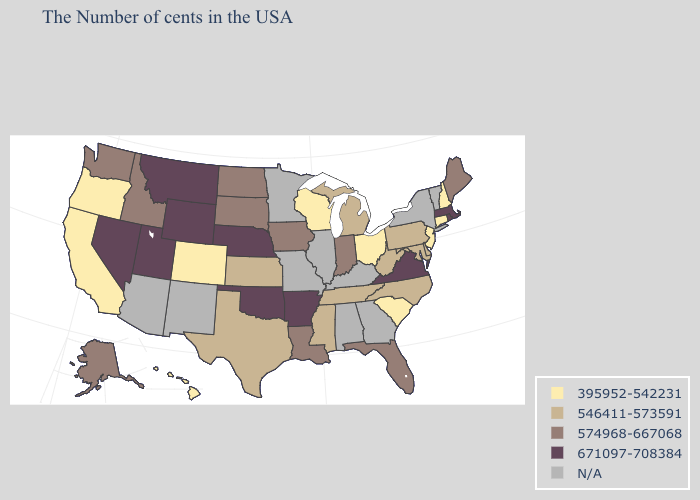Among the states that border Tennessee , does Virginia have the highest value?
Answer briefly. Yes. Name the states that have a value in the range 574968-667068?
Answer briefly. Maine, Florida, Indiana, Louisiana, Iowa, South Dakota, North Dakota, Idaho, Washington, Alaska. Does the first symbol in the legend represent the smallest category?
Short answer required. Yes. Which states have the highest value in the USA?
Short answer required. Massachusetts, Rhode Island, Virginia, Arkansas, Nebraska, Oklahoma, Wyoming, Utah, Montana, Nevada. Which states have the lowest value in the South?
Answer briefly. South Carolina. What is the value of Tennessee?
Be succinct. 546411-573591. Name the states that have a value in the range N/A?
Quick response, please. Vermont, New York, Georgia, Kentucky, Alabama, Illinois, Missouri, Minnesota, New Mexico, Arizona. What is the lowest value in states that border Texas?
Keep it brief. 574968-667068. What is the value of Iowa?
Short answer required. 574968-667068. Among the states that border Oregon , does Idaho have the highest value?
Quick response, please. No. Which states have the lowest value in the USA?
Concise answer only. New Hampshire, Connecticut, New Jersey, South Carolina, Ohio, Wisconsin, Colorado, California, Oregon, Hawaii. Name the states that have a value in the range 395952-542231?
Quick response, please. New Hampshire, Connecticut, New Jersey, South Carolina, Ohio, Wisconsin, Colorado, California, Oregon, Hawaii. Name the states that have a value in the range N/A?
Be succinct. Vermont, New York, Georgia, Kentucky, Alabama, Illinois, Missouri, Minnesota, New Mexico, Arizona. Which states have the lowest value in the West?
Answer briefly. Colorado, California, Oregon, Hawaii. 